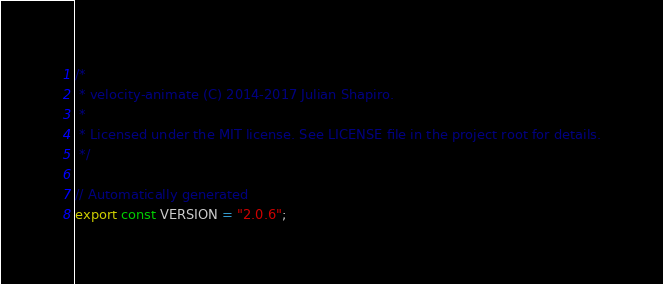Convert code to text. <code><loc_0><loc_0><loc_500><loc_500><_TypeScript_>/*
 * velocity-animate (C) 2014-2017 Julian Shapiro.
 *
 * Licensed under the MIT license. See LICENSE file in the project root for details.
 */

// Automatically generated
export const VERSION = "2.0.6";
</code> 